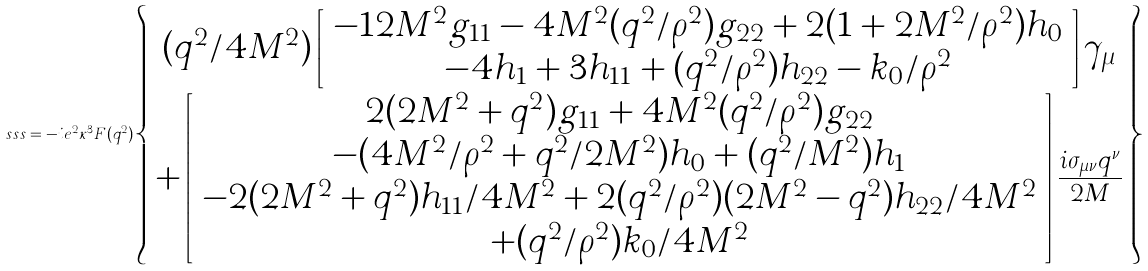Convert formula to latex. <formula><loc_0><loc_0><loc_500><loc_500>s s s = - i e ^ { 2 } \kappa ^ { 3 } F ( q ^ { 2 } ) \left \{ \begin{array} { c } ( q ^ { 2 } / 4 M ^ { 2 } ) \left [ \begin{array} { c } - 1 2 M ^ { 2 } g _ { 1 1 } - 4 M ^ { 2 } ( q ^ { 2 } / \rho ^ { 2 } ) g _ { 2 2 } + 2 ( 1 + 2 M ^ { 2 } / \rho ^ { 2 } ) h _ { 0 } \\ - 4 h _ { 1 } + 3 h _ { 1 1 } + ( q ^ { 2 } / \rho ^ { 2 } ) h _ { 2 2 } - k _ { 0 } / \rho ^ { 2 } \end{array} \right ] \gamma _ { \mu } \\ + \left [ \begin{array} { c } 2 ( 2 M ^ { 2 } + q ^ { 2 } ) g _ { 1 1 } + 4 M ^ { 2 } ( q ^ { 2 } / \rho ^ { 2 } ) g _ { 2 2 } \\ - ( 4 M ^ { 2 } / \rho ^ { 2 } + q ^ { 2 } / 2 M ^ { 2 } ) h _ { 0 } + ( q ^ { 2 } / M ^ { 2 } ) h _ { 1 } \\ - 2 ( 2 M ^ { 2 } + q ^ { 2 } ) h _ { 1 1 } / 4 M ^ { 2 } + 2 ( q ^ { 2 } / \rho ^ { 2 } ) ( 2 M ^ { 2 } - q ^ { 2 } ) h _ { 2 2 } / 4 M ^ { 2 } \\ + ( q ^ { 2 } / \rho ^ { 2 } ) k _ { 0 } / 4 M ^ { 2 } \end{array} \right ] { \frac { i \sigma _ { \mu \nu } q ^ { \nu } } { 2 M } } \end{array} \right \}</formula> 